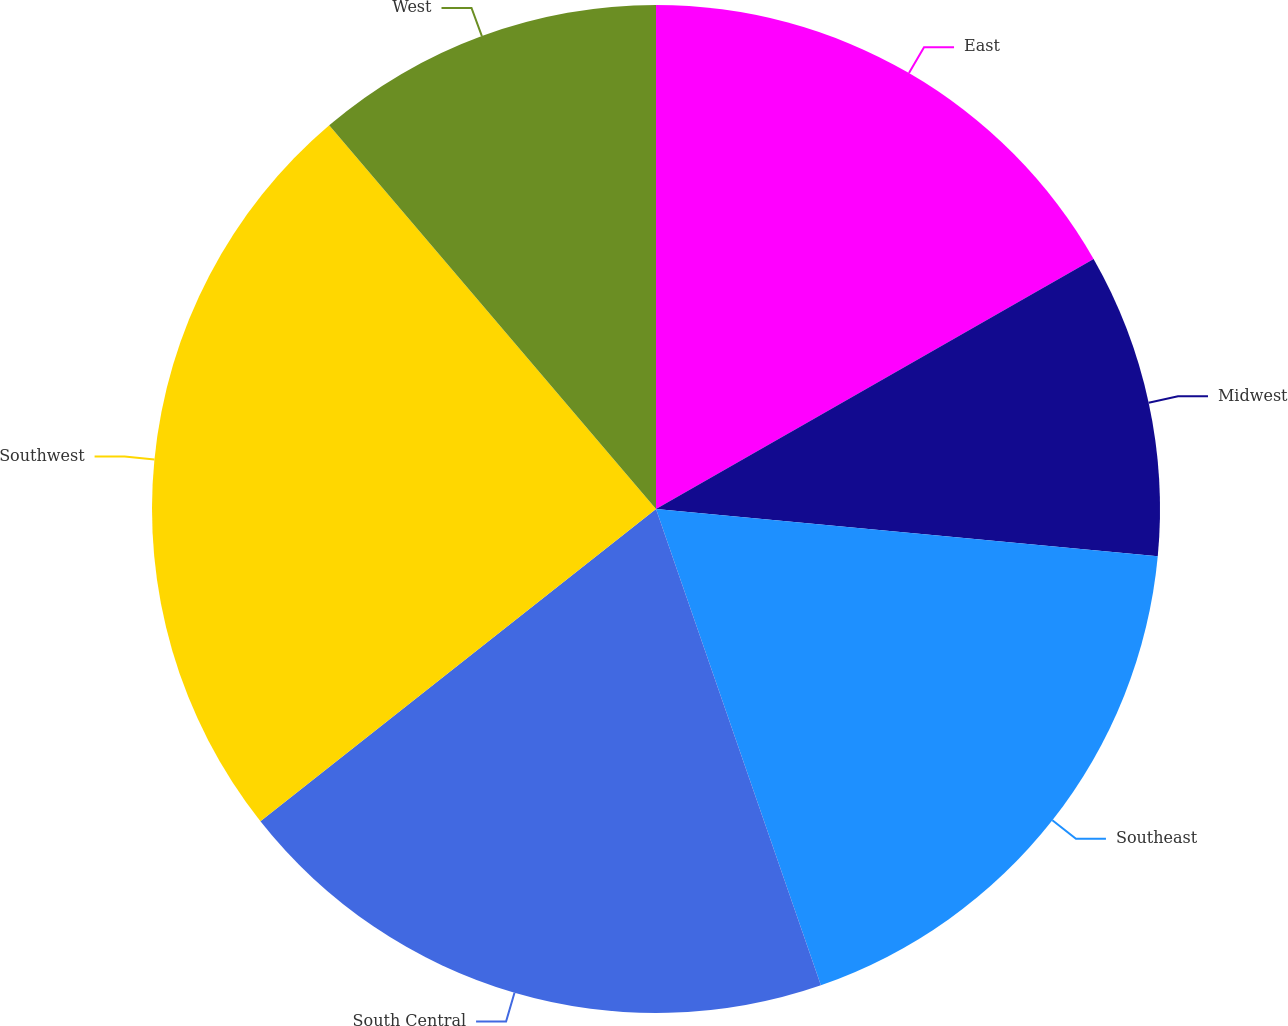Convert chart. <chart><loc_0><loc_0><loc_500><loc_500><pie_chart><fcel>East<fcel>Midwest<fcel>Southeast<fcel>South Central<fcel>Southwest<fcel>West<nl><fcel>16.74%<fcel>9.76%<fcel>18.2%<fcel>19.67%<fcel>24.41%<fcel>11.23%<nl></chart> 